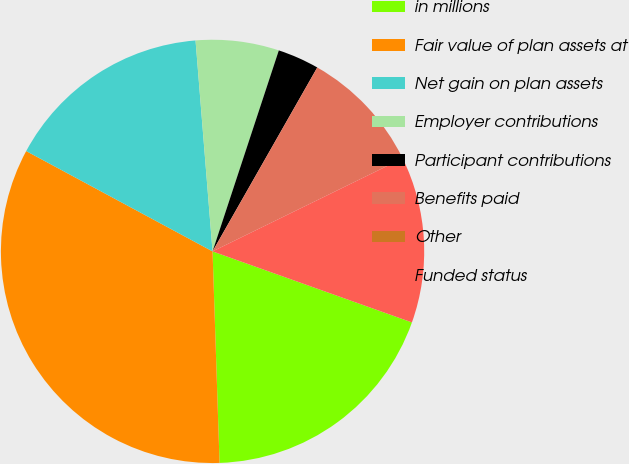Convert chart. <chart><loc_0><loc_0><loc_500><loc_500><pie_chart><fcel>in millions<fcel>Fair value of plan assets at<fcel>Net gain on plan assets<fcel>Employer contributions<fcel>Participant contributions<fcel>Benefits paid<fcel>Other<fcel>Funded status<nl><fcel>19.03%<fcel>33.39%<fcel>15.86%<fcel>6.35%<fcel>3.17%<fcel>9.52%<fcel>0.0%<fcel>12.69%<nl></chart> 